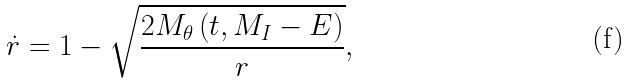<formula> <loc_0><loc_0><loc_500><loc_500>\dot { r } = 1 - \sqrt { \frac { 2 M _ { \theta } \left ( t , M _ { I } - E \right ) } { r } } ,</formula> 